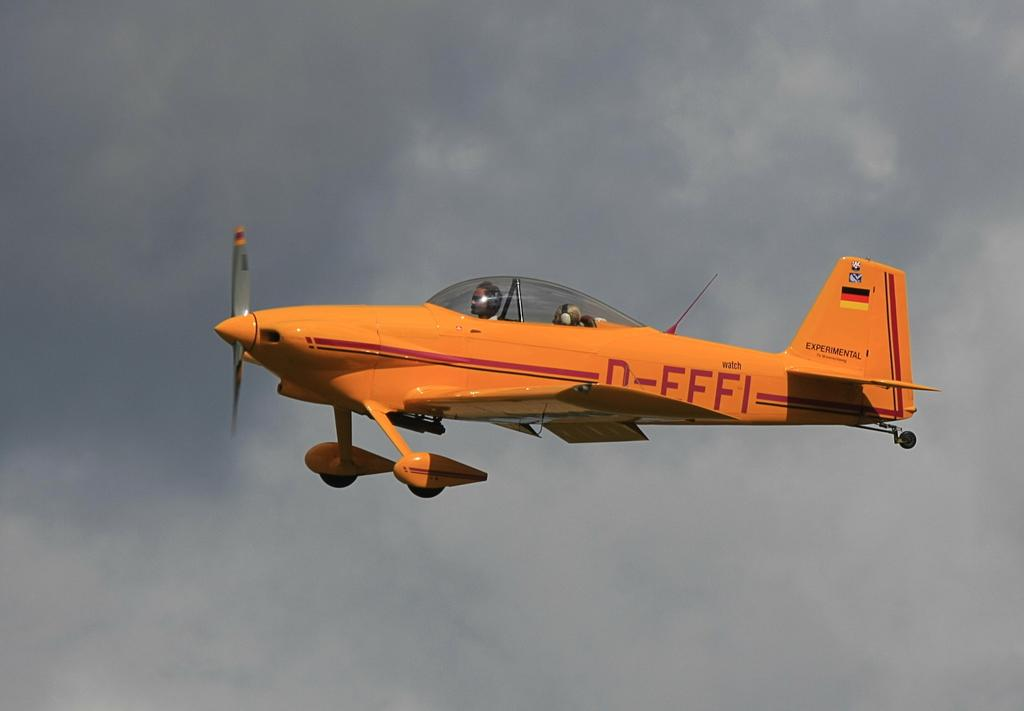How many people are in the image? There are two persons in the image. Where are the two persons located? The two persons are sitting in an airplane. What is the airplane doing in the image? The airplane is flying in the sky. What type of cave can be seen in the image? There is no cave present in the image; it features two persons sitting in an airplane that is flying in the sky. What color is the vest worn by the person in the image? There is no person wearing a vest in the image. 